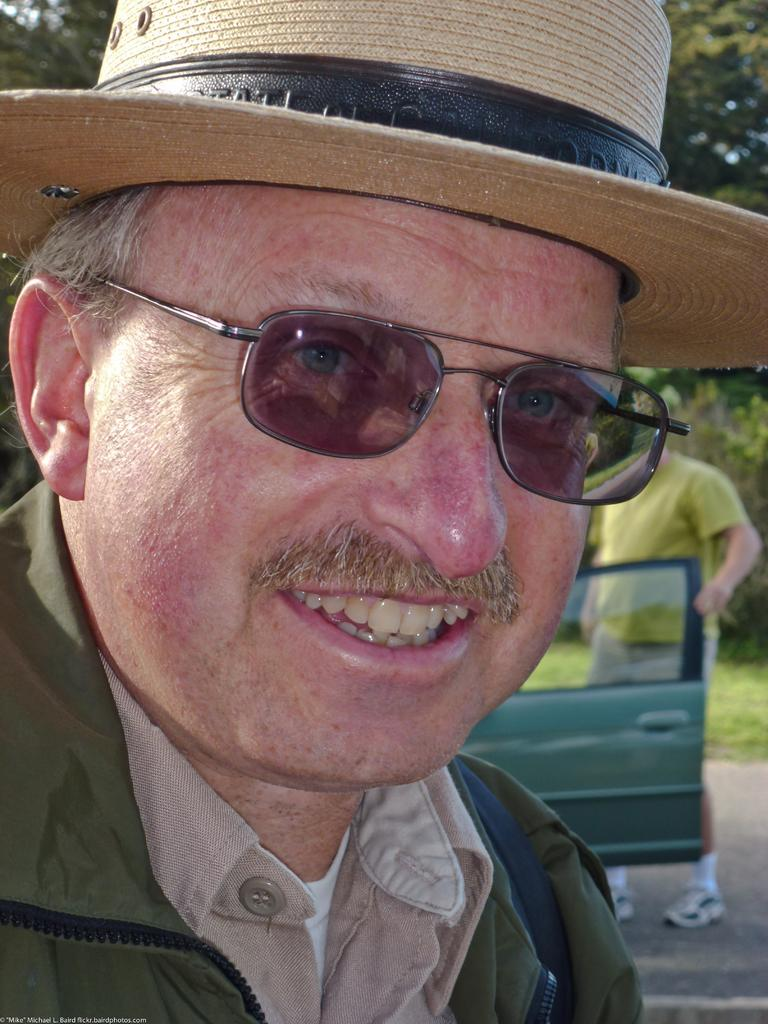Who is present in the image? There is a man and another person in the image. What is the man in the image doing? The man is laughing. What is the second person in the image doing? The second person is holding the door of a vehicle. What color is the scarecrow in the image? There is no scarecrow present in the image. How much credit does the man in the image have on his credit card? The image does not provide any information about the man's credit card or credit limit. 